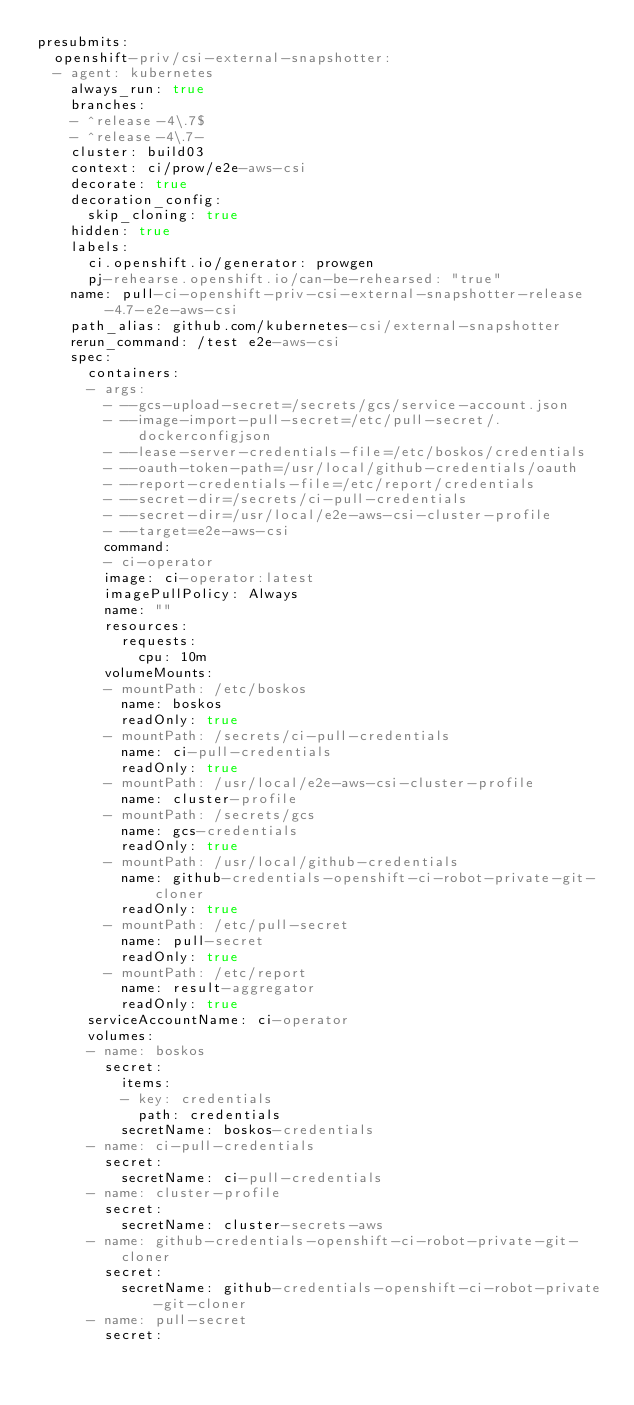<code> <loc_0><loc_0><loc_500><loc_500><_YAML_>presubmits:
  openshift-priv/csi-external-snapshotter:
  - agent: kubernetes
    always_run: true
    branches:
    - ^release-4\.7$
    - ^release-4\.7-
    cluster: build03
    context: ci/prow/e2e-aws-csi
    decorate: true
    decoration_config:
      skip_cloning: true
    hidden: true
    labels:
      ci.openshift.io/generator: prowgen
      pj-rehearse.openshift.io/can-be-rehearsed: "true"
    name: pull-ci-openshift-priv-csi-external-snapshotter-release-4.7-e2e-aws-csi
    path_alias: github.com/kubernetes-csi/external-snapshotter
    rerun_command: /test e2e-aws-csi
    spec:
      containers:
      - args:
        - --gcs-upload-secret=/secrets/gcs/service-account.json
        - --image-import-pull-secret=/etc/pull-secret/.dockerconfigjson
        - --lease-server-credentials-file=/etc/boskos/credentials
        - --oauth-token-path=/usr/local/github-credentials/oauth
        - --report-credentials-file=/etc/report/credentials
        - --secret-dir=/secrets/ci-pull-credentials
        - --secret-dir=/usr/local/e2e-aws-csi-cluster-profile
        - --target=e2e-aws-csi
        command:
        - ci-operator
        image: ci-operator:latest
        imagePullPolicy: Always
        name: ""
        resources:
          requests:
            cpu: 10m
        volumeMounts:
        - mountPath: /etc/boskos
          name: boskos
          readOnly: true
        - mountPath: /secrets/ci-pull-credentials
          name: ci-pull-credentials
          readOnly: true
        - mountPath: /usr/local/e2e-aws-csi-cluster-profile
          name: cluster-profile
        - mountPath: /secrets/gcs
          name: gcs-credentials
          readOnly: true
        - mountPath: /usr/local/github-credentials
          name: github-credentials-openshift-ci-robot-private-git-cloner
          readOnly: true
        - mountPath: /etc/pull-secret
          name: pull-secret
          readOnly: true
        - mountPath: /etc/report
          name: result-aggregator
          readOnly: true
      serviceAccountName: ci-operator
      volumes:
      - name: boskos
        secret:
          items:
          - key: credentials
            path: credentials
          secretName: boskos-credentials
      - name: ci-pull-credentials
        secret:
          secretName: ci-pull-credentials
      - name: cluster-profile
        secret:
          secretName: cluster-secrets-aws
      - name: github-credentials-openshift-ci-robot-private-git-cloner
        secret:
          secretName: github-credentials-openshift-ci-robot-private-git-cloner
      - name: pull-secret
        secret:</code> 